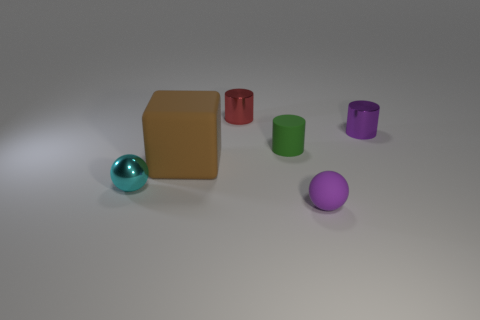Subtract all green cylinders. How many cylinders are left? 2 Add 2 large cyan metallic cylinders. How many objects exist? 8 Subtract all balls. How many objects are left? 4 Subtract all large matte things. Subtract all large brown matte things. How many objects are left? 4 Add 1 brown cubes. How many brown cubes are left? 2 Add 3 purple metal objects. How many purple metal objects exist? 4 Subtract 0 blue cubes. How many objects are left? 6 